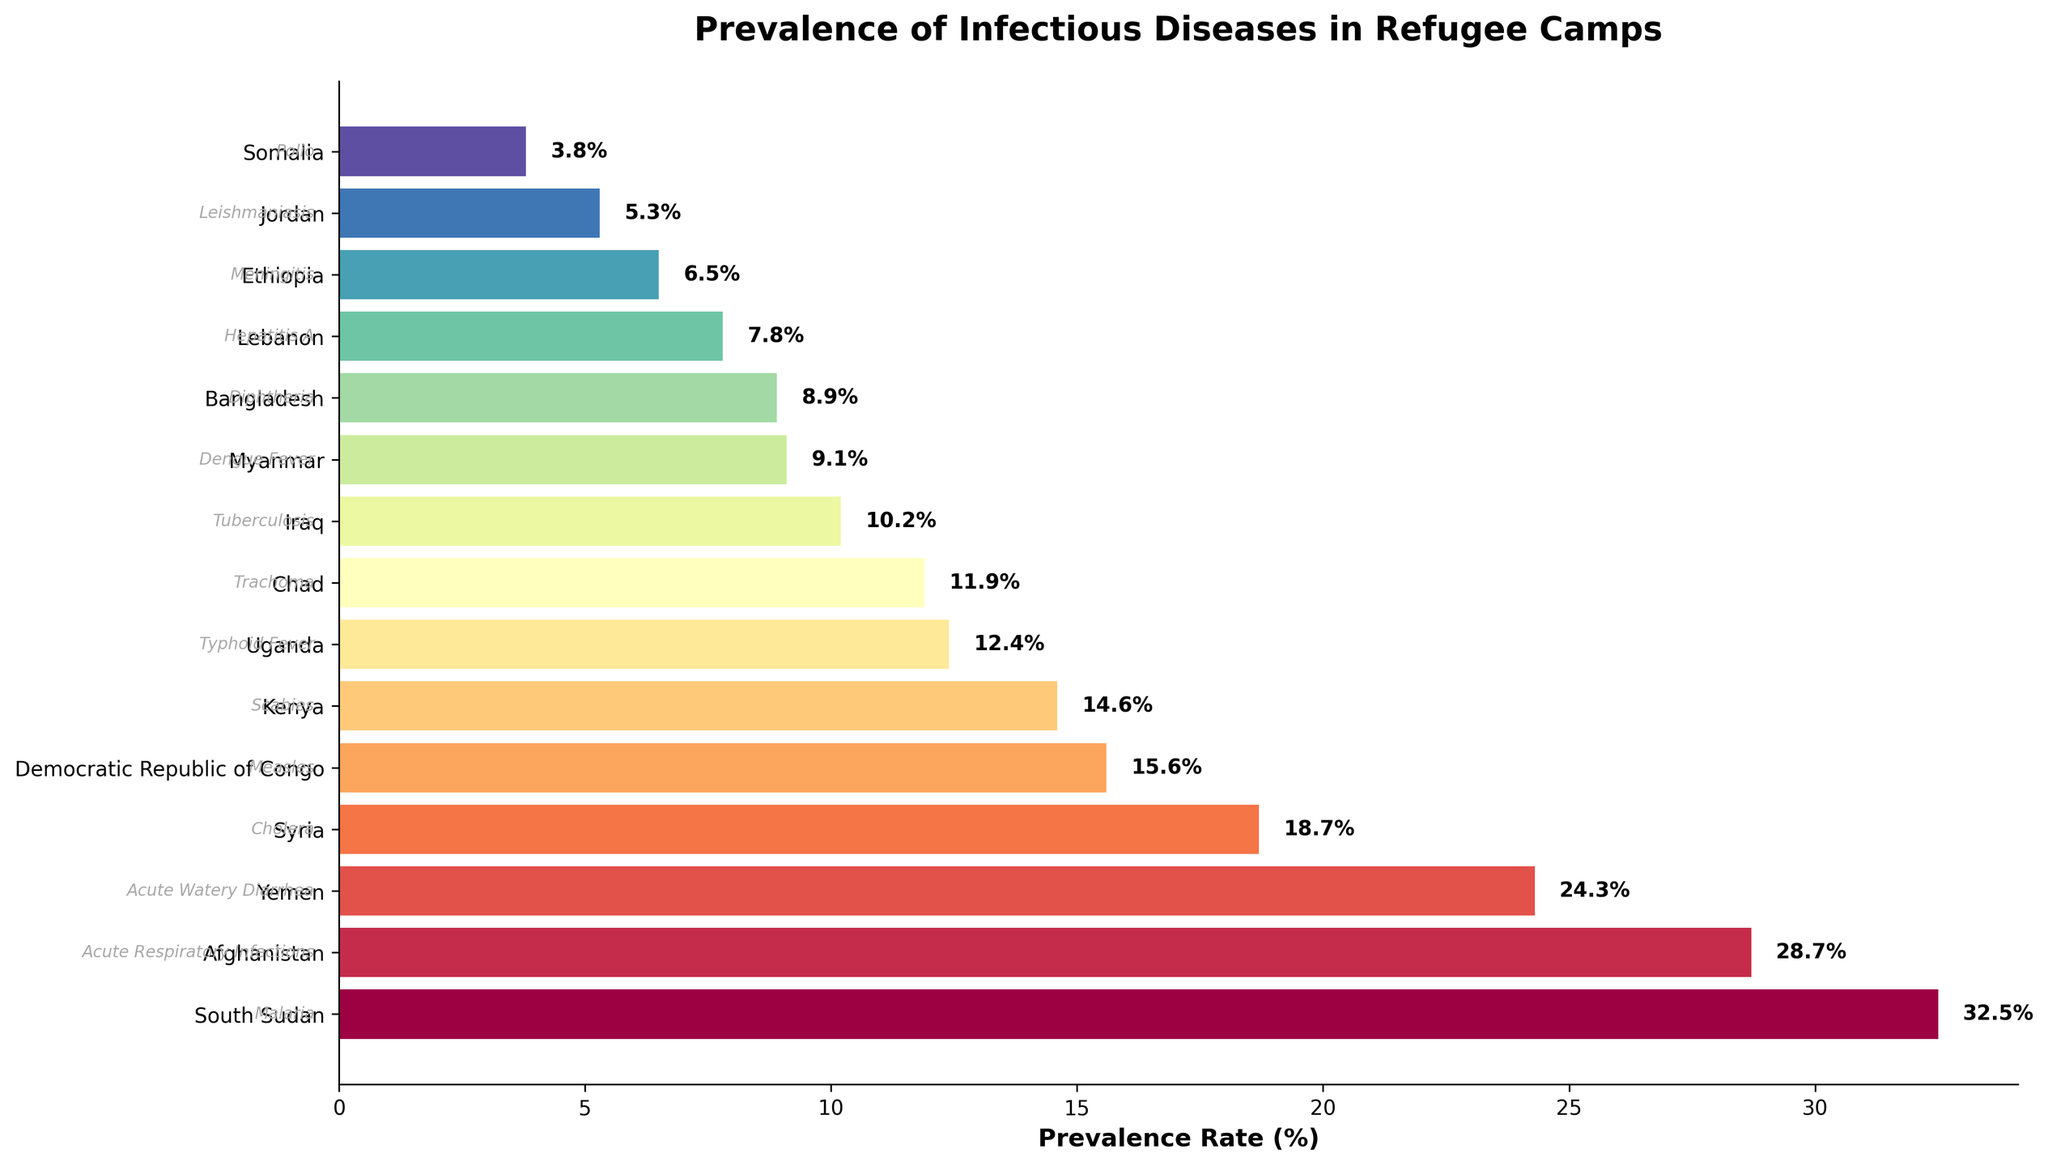Which country has the highest prevalence rate of infectious diseases in refugee camps? The country with the highest bar in the horizontal bar chart represents the highest prevalence rate. The first country listed from the top in a descending-sorted chart is South Sudan with a prevalence rate of 32.5%.
Answer: South Sudan Which disease has the lowest prevalence rate in refugee camps? The disease associated with the country having the lowest bar in the chart indicates the lowest prevalence rate. The last country listed from the top in a descending-sorted chart is Somalia, experiencing Polio with a prevalence rate of 3.8%.
Answer: Polio What is the difference in prevalence rates between the country with the highest and the country with the lowest rate? Subtract the prevalence rate of the country with the lowest prevalence (3.8% from Somalia) from the prevalence rate of the country with the highest prevalence (32.5% from South Sudan): 32.5% - 3.8% = 28.7%.
Answer: 28.7% Which country has a higher prevalence rate of infectious diseases, Yemen or Syria, and by how much? Compare the heights of the bars for Yemen and Syria. Yemen has a prevalence rate of 24.3% and Syria has 18.7%. The difference is 24.3% - 18.7% = 5.6%.
Answer: Yemen by 5.6% What is the combined prevalence rate of infectious diseases in Somalia and Kenya? Add the prevalence rates of Somalia (3.8%) and Kenya (14.6%): 3.8% + 14.6% = 18.4%.
Answer: 18.4% Rank Iraq, Ethiopia, and Myanmar in terms of their prevalence rates from highest to lowest. Identify and compare the bars for Iraq (10.2%), Ethiopia (6.5%), and Myanmar (9.1%). The order from highest to lowest is Iraq (10.2%), Myanmar (9.1%), and Ethiopia (6.5%).
Answer: Iraq, Myanmar, Ethiopia Which country has a prevalence rate closest to 10%? Identify the bar closest to a length representing a 10% prevalence rate. Iraq's bar is the closest with a prevalence rate of 10.2%.
Answer: Iraq How many countries have a prevalence rate higher than 20%? Count the number of bars that extend beyond the 20% mark. The countries are South Sudan with 32.5%, Yemen with 24.3%, and Afghanistan with 28.7%, making it three countries.
Answer: 3 Which infectious disease has a higher prevalence rate in refugee camps, Measles or Diphtheria, and in which country is it prevalent? Compare the bars labeled with Measles (Democratic Republic of Congo with 15.6%) and Diphtheria (Bangladesh with 8.9%). Measles has a higher prevalence rate and is prevalent in the Democratic Republic of Congo.
Answer: Measles in the Democratic Republic of Congo Is the prevalence rate of Tuberculosis in Iraq higher, lower, or equal to the prevalence rate of Meningitis in Ethiopia? Compare the lengths of the bars for Tuberculosis (10.2% in Iraq) and Meningitis (6.5% in Ethiopia). Tuberculosis has a higher prevalence rate.
Answer: Higher 